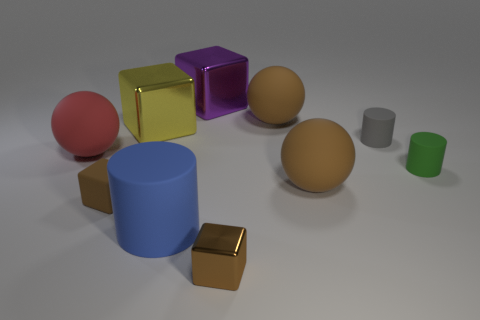Is there anything else that is the same material as the big yellow thing?
Your answer should be very brief. Yes. There is another tiny block that is the same color as the small matte cube; what is its material?
Make the answer very short. Metal. What material is the gray cylinder that is the same size as the green rubber thing?
Offer a very short reply. Rubber. Are there more blue cubes than gray rubber cylinders?
Your answer should be compact. No. There is a matte ball left of the small brown object to the left of the purple shiny block; what is its size?
Your answer should be very brief. Large. What shape is the green thing that is the same size as the gray matte object?
Provide a succinct answer. Cylinder. The small brown thing that is left of the metal cube in front of the large sphere that is left of the yellow thing is what shape?
Your answer should be very brief. Cube. There is a tiny thing that is in front of the rubber cube; is it the same color as the big ball that is behind the red ball?
Provide a succinct answer. Yes. What number of red balls are there?
Offer a terse response. 1. Are there any brown matte spheres in front of the tiny green matte thing?
Provide a succinct answer. Yes. 